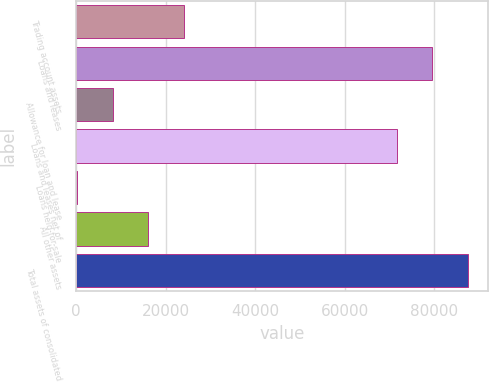Convert chart. <chart><loc_0><loc_0><loc_500><loc_500><bar_chart><fcel>Trading account assets<fcel>Loans and leases<fcel>Allowance for loan and lease<fcel>Loans and leases net of<fcel>Loans held-for-sale<fcel>All other assets<fcel>Total assets of consolidated<nl><fcel>24134<fcel>79576<fcel>8234<fcel>71626<fcel>284<fcel>16184<fcel>87526<nl></chart> 